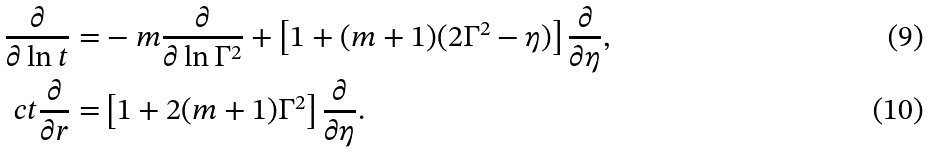<formula> <loc_0><loc_0><loc_500><loc_500>\frac { \partial } { \partial \ln t } = & - m \frac { \partial } { \partial \ln \Gamma ^ { 2 } } + \left [ 1 + ( m + 1 ) ( 2 \Gamma ^ { 2 } - \eta ) \right ] \frac { \partial } { \partial \eta } , \\ c t \frac { \partial } { \partial r } = & \left [ 1 + 2 ( m + 1 ) \Gamma ^ { 2 } \right ] \frac { \partial } { \partial \eta } .</formula> 